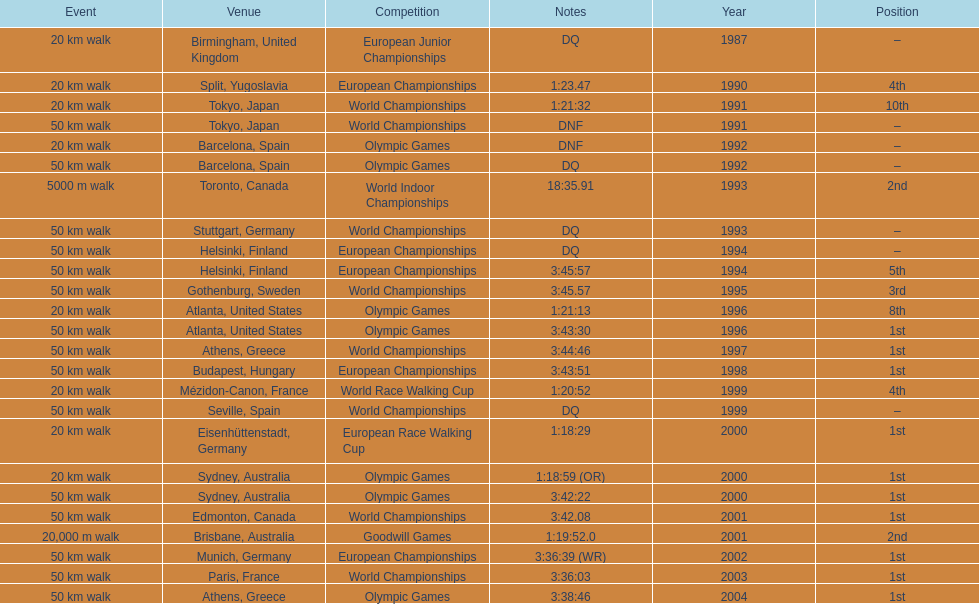How many times was first place listed as the position? 10. 